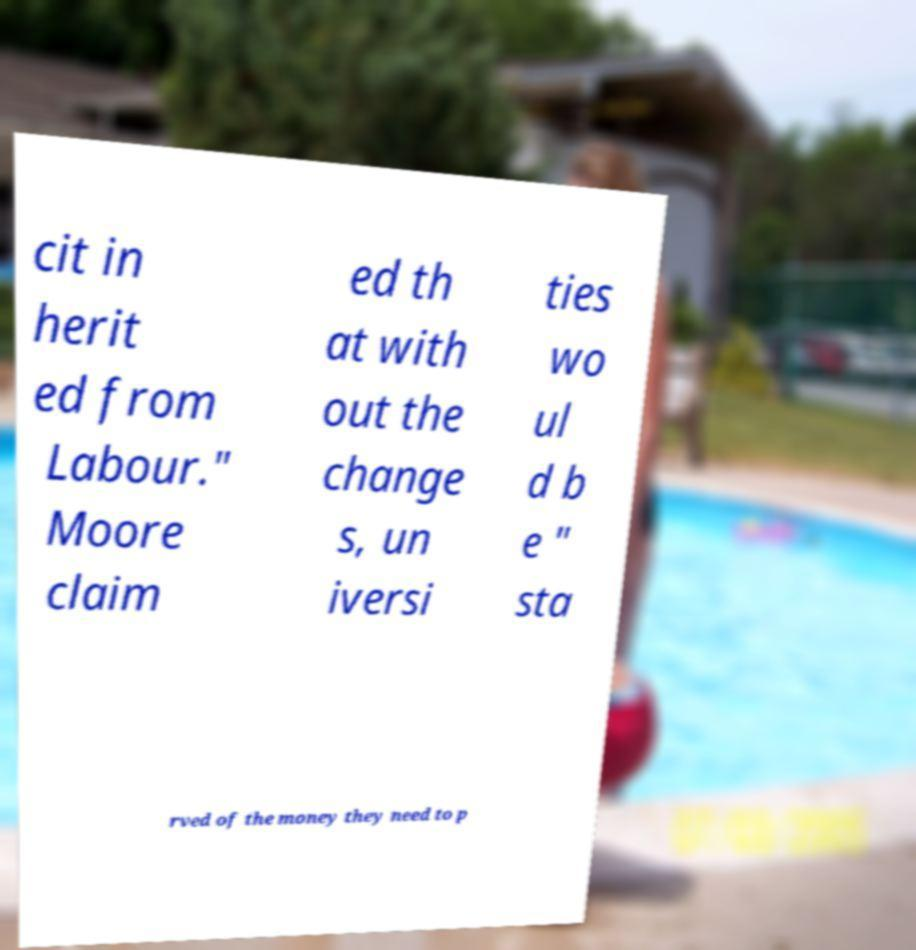Please identify and transcribe the text found in this image. cit in herit ed from Labour." Moore claim ed th at with out the change s, un iversi ties wo ul d b e " sta rved of the money they need to p 